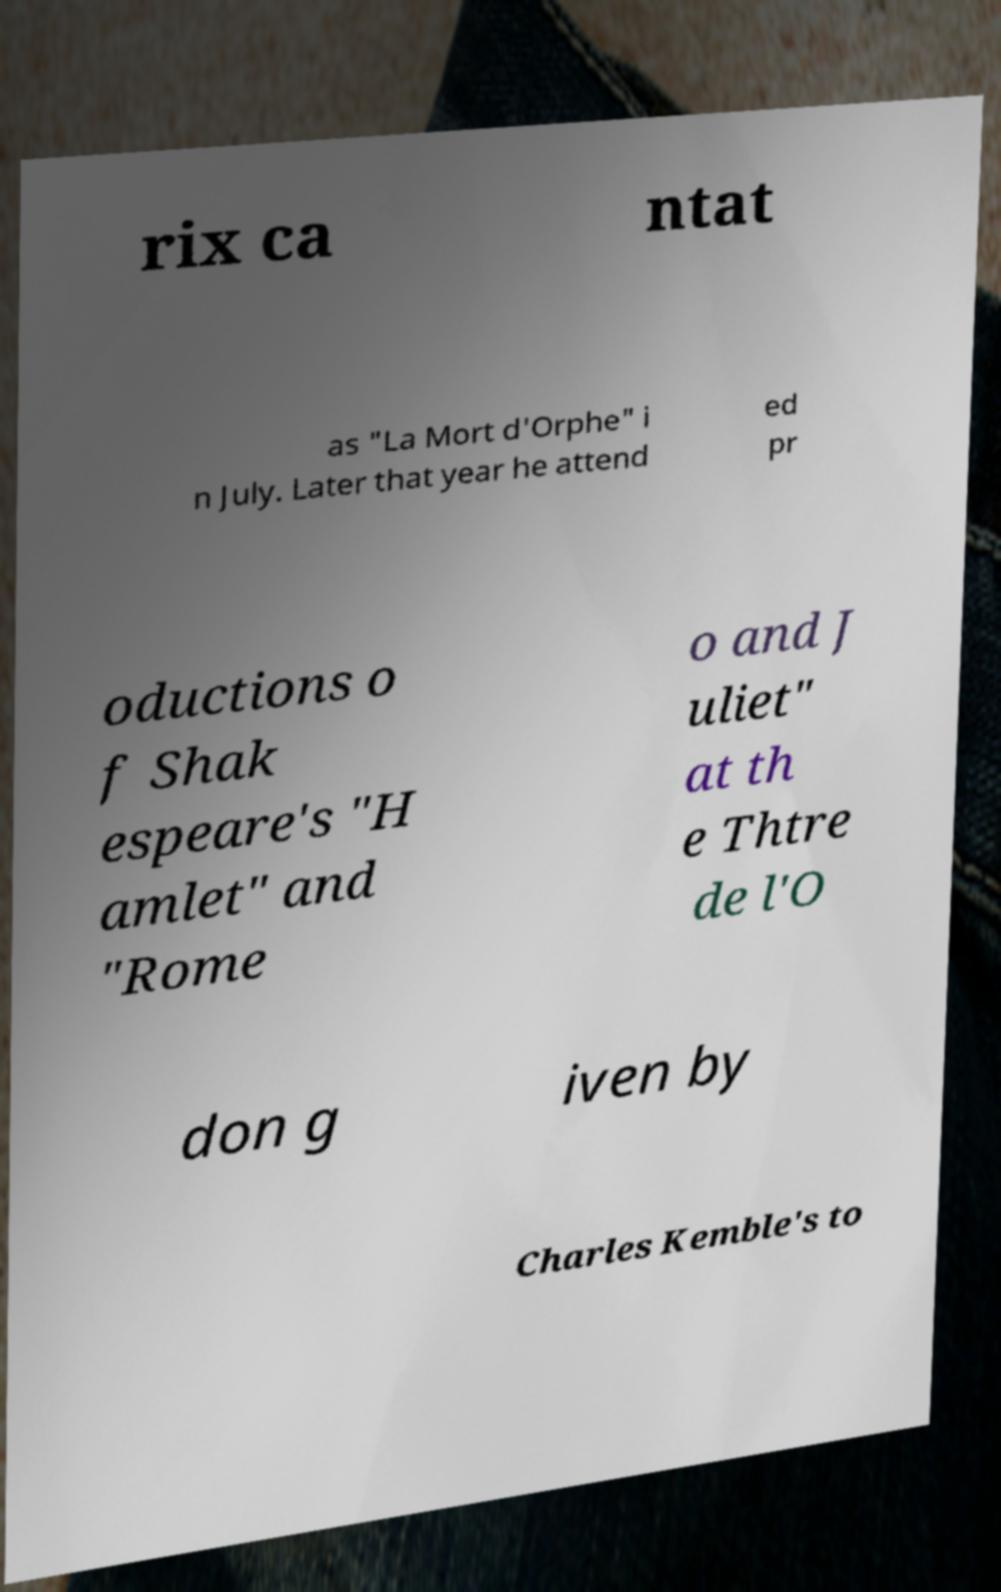Can you accurately transcribe the text from the provided image for me? rix ca ntat as "La Mort d'Orphe" i n July. Later that year he attend ed pr oductions o f Shak espeare's "H amlet" and "Rome o and J uliet" at th e Thtre de l'O don g iven by Charles Kemble's to 